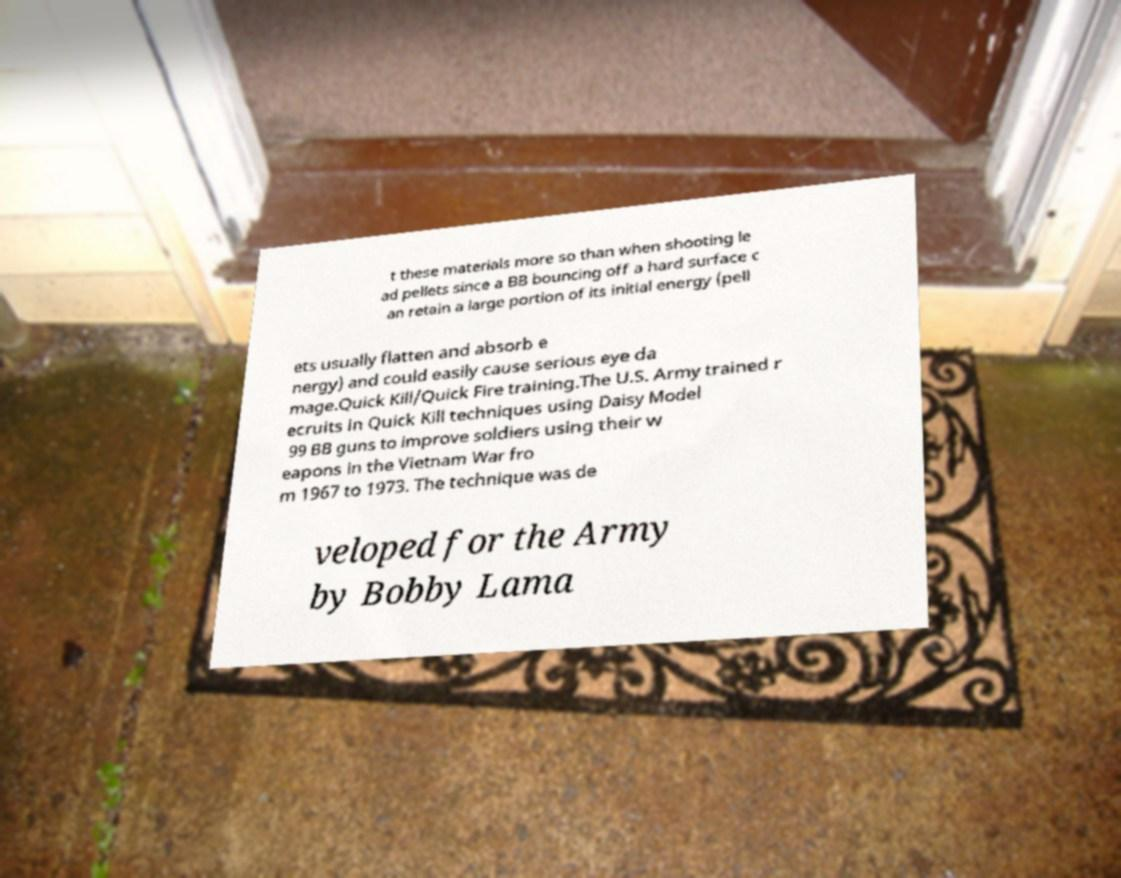I need the written content from this picture converted into text. Can you do that? t these materials more so than when shooting le ad pellets since a BB bouncing off a hard surface c an retain a large portion of its initial energy (pell ets usually flatten and absorb e nergy) and could easily cause serious eye da mage.Quick Kill/Quick Fire training.The U.S. Army trained r ecruits in Quick Kill techniques using Daisy Model 99 BB guns to improve soldiers using their w eapons in the Vietnam War fro m 1967 to 1973. The technique was de veloped for the Army by Bobby Lama 